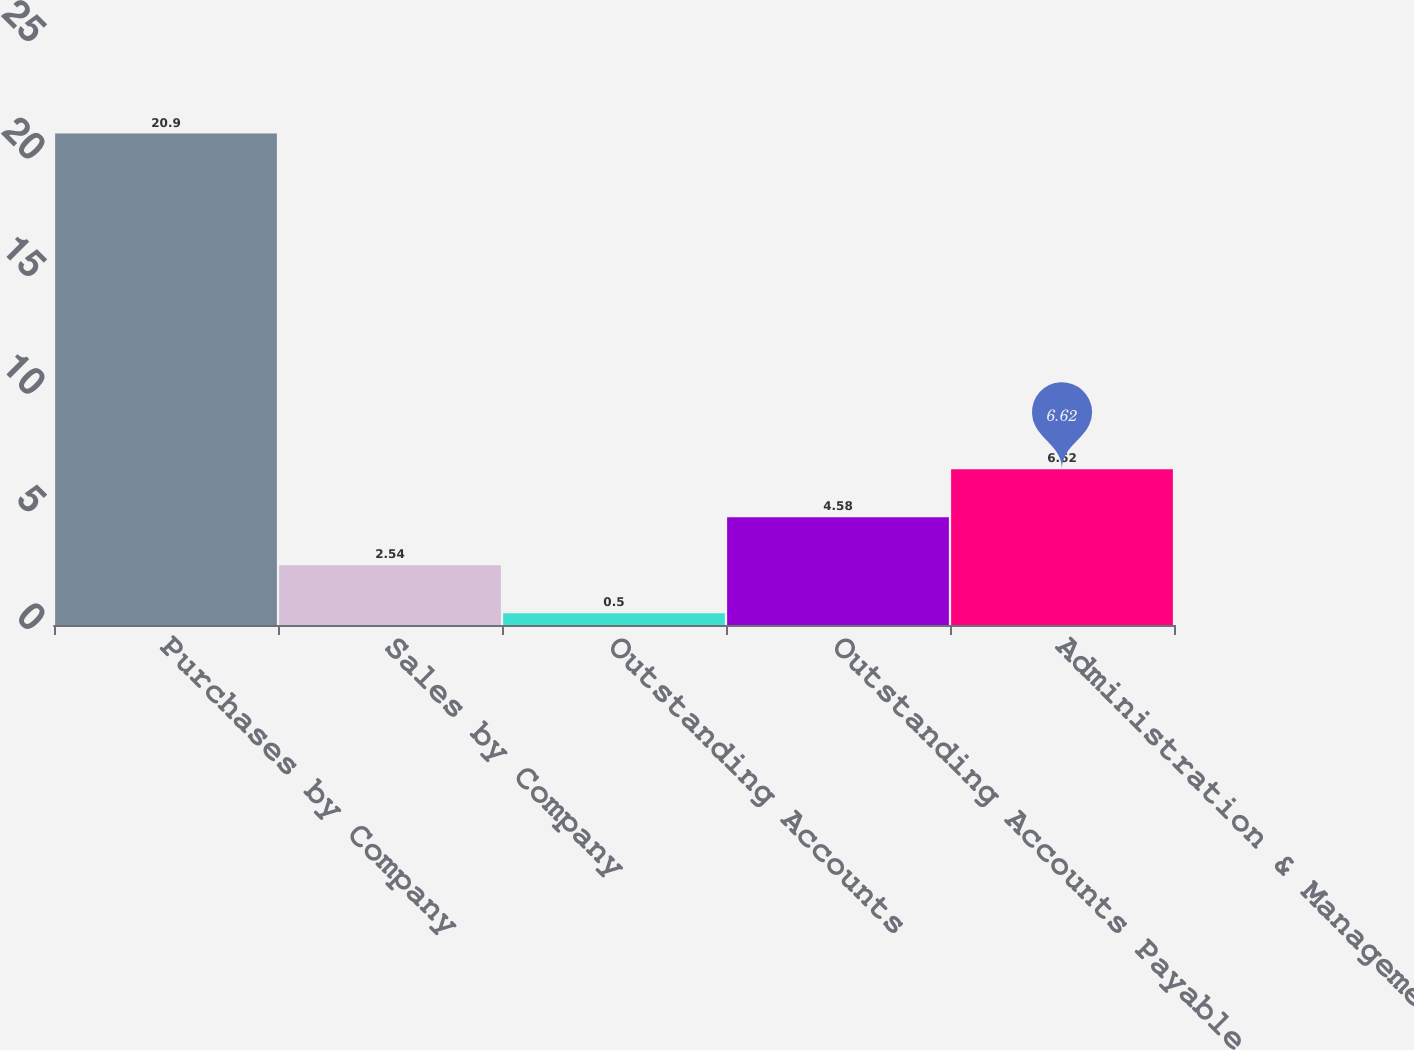Convert chart to OTSL. <chart><loc_0><loc_0><loc_500><loc_500><bar_chart><fcel>Purchases by Company<fcel>Sales by Company<fcel>Outstanding Accounts<fcel>Outstanding Accounts Payable<fcel>Administration & Management<nl><fcel>20.9<fcel>2.54<fcel>0.5<fcel>4.58<fcel>6.62<nl></chart> 